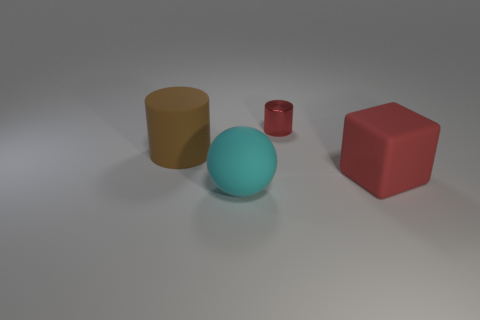Add 3 matte spheres. How many objects exist? 7 Subtract 2 cylinders. How many cylinders are left? 0 Subtract all red cylinders. How many cylinders are left? 1 Subtract all spheres. How many objects are left? 3 Add 3 matte objects. How many matte objects exist? 6 Subtract 0 yellow balls. How many objects are left? 4 Subtract all red cylinders. Subtract all gray blocks. How many cylinders are left? 1 Subtract all large matte objects. Subtract all big purple matte cylinders. How many objects are left? 1 Add 1 red rubber objects. How many red rubber objects are left? 2 